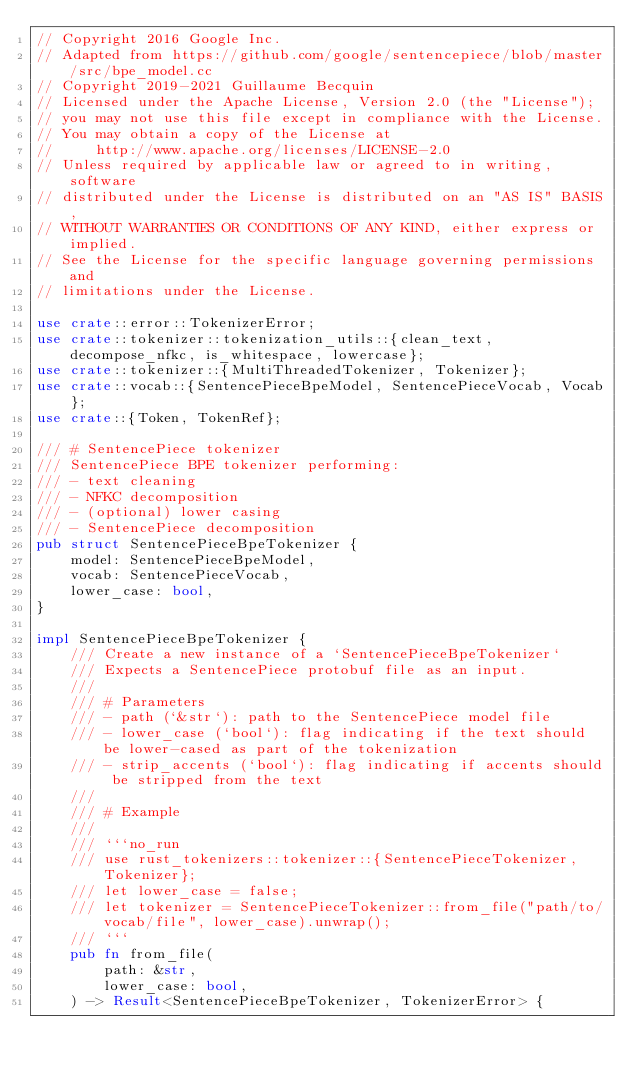<code> <loc_0><loc_0><loc_500><loc_500><_Rust_>// Copyright 2016 Google Inc.
// Adapted from https://github.com/google/sentencepiece/blob/master/src/bpe_model.cc
// Copyright 2019-2021 Guillaume Becquin
// Licensed under the Apache License, Version 2.0 (the "License");
// you may not use this file except in compliance with the License.
// You may obtain a copy of the License at
//     http://www.apache.org/licenses/LICENSE-2.0
// Unless required by applicable law or agreed to in writing, software
// distributed under the License is distributed on an "AS IS" BASIS,
// WITHOUT WARRANTIES OR CONDITIONS OF ANY KIND, either express or implied.
// See the License for the specific language governing permissions and
// limitations under the License.

use crate::error::TokenizerError;
use crate::tokenizer::tokenization_utils::{clean_text, decompose_nfkc, is_whitespace, lowercase};
use crate::tokenizer::{MultiThreadedTokenizer, Tokenizer};
use crate::vocab::{SentencePieceBpeModel, SentencePieceVocab, Vocab};
use crate::{Token, TokenRef};

/// # SentencePiece tokenizer
/// SentencePiece BPE tokenizer performing:
/// - text cleaning
/// - NFKC decomposition
/// - (optional) lower casing
/// - SentencePiece decomposition
pub struct SentencePieceBpeTokenizer {
    model: SentencePieceBpeModel,
    vocab: SentencePieceVocab,
    lower_case: bool,
}

impl SentencePieceBpeTokenizer {
    /// Create a new instance of a `SentencePieceBpeTokenizer`
    /// Expects a SentencePiece protobuf file as an input.
    ///
    /// # Parameters
    /// - path (`&str`): path to the SentencePiece model file
    /// - lower_case (`bool`): flag indicating if the text should be lower-cased as part of the tokenization
    /// - strip_accents (`bool`): flag indicating if accents should be stripped from the text
    ///
    /// # Example
    ///
    /// ```no_run
    /// use rust_tokenizers::tokenizer::{SentencePieceTokenizer, Tokenizer};
    /// let lower_case = false;
    /// let tokenizer = SentencePieceTokenizer::from_file("path/to/vocab/file", lower_case).unwrap();
    /// ```
    pub fn from_file(
        path: &str,
        lower_case: bool,
    ) -> Result<SentencePieceBpeTokenizer, TokenizerError> {</code> 